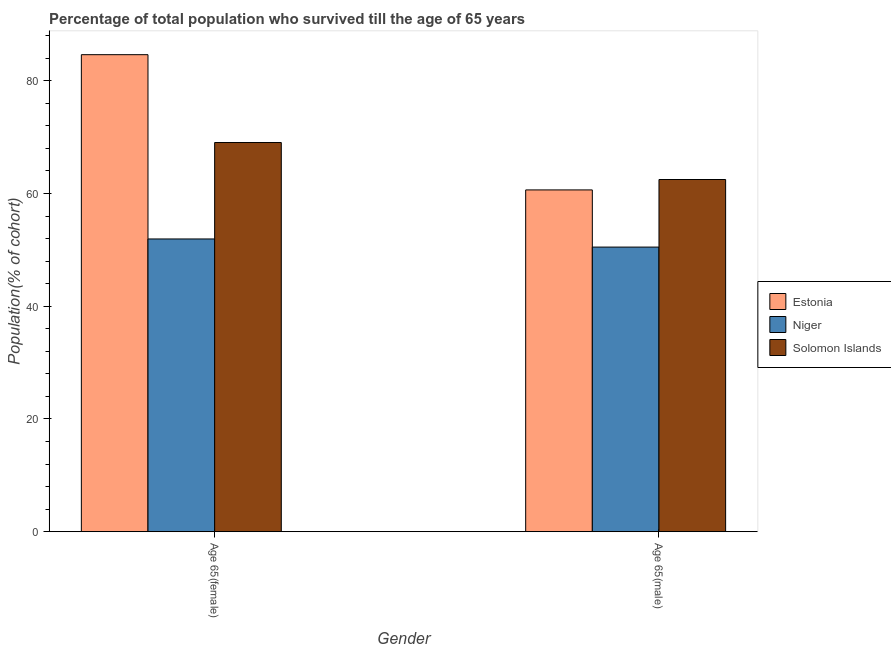How many different coloured bars are there?
Offer a terse response. 3. Are the number of bars per tick equal to the number of legend labels?
Make the answer very short. Yes. How many bars are there on the 2nd tick from the left?
Offer a terse response. 3. How many bars are there on the 2nd tick from the right?
Your answer should be very brief. 3. What is the label of the 1st group of bars from the left?
Give a very brief answer. Age 65(female). What is the percentage of male population who survived till age of 65 in Niger?
Your answer should be very brief. 50.5. Across all countries, what is the maximum percentage of male population who survived till age of 65?
Provide a succinct answer. 62.49. Across all countries, what is the minimum percentage of female population who survived till age of 65?
Your response must be concise. 51.94. In which country was the percentage of female population who survived till age of 65 maximum?
Offer a very short reply. Estonia. In which country was the percentage of male population who survived till age of 65 minimum?
Your response must be concise. Niger. What is the total percentage of male population who survived till age of 65 in the graph?
Your response must be concise. 173.63. What is the difference between the percentage of female population who survived till age of 65 in Niger and that in Solomon Islands?
Your response must be concise. -17.11. What is the difference between the percentage of male population who survived till age of 65 in Niger and the percentage of female population who survived till age of 65 in Solomon Islands?
Offer a terse response. -18.55. What is the average percentage of female population who survived till age of 65 per country?
Your response must be concise. 68.54. What is the difference between the percentage of male population who survived till age of 65 and percentage of female population who survived till age of 65 in Solomon Islands?
Provide a succinct answer. -6.56. What is the ratio of the percentage of male population who survived till age of 65 in Niger to that in Estonia?
Offer a very short reply. 0.83. What does the 3rd bar from the left in Age 65(female) represents?
Keep it short and to the point. Solomon Islands. What does the 2nd bar from the right in Age 65(female) represents?
Offer a terse response. Niger. Are all the bars in the graph horizontal?
Offer a very short reply. No. Are the values on the major ticks of Y-axis written in scientific E-notation?
Keep it short and to the point. No. How many legend labels are there?
Ensure brevity in your answer.  3. What is the title of the graph?
Offer a very short reply. Percentage of total population who survived till the age of 65 years. Does "Syrian Arab Republic" appear as one of the legend labels in the graph?
Your response must be concise. No. What is the label or title of the X-axis?
Offer a very short reply. Gender. What is the label or title of the Y-axis?
Make the answer very short. Population(% of cohort). What is the Population(% of cohort) in Estonia in Age 65(female)?
Ensure brevity in your answer.  84.64. What is the Population(% of cohort) of Niger in Age 65(female)?
Your answer should be very brief. 51.94. What is the Population(% of cohort) in Solomon Islands in Age 65(female)?
Your answer should be compact. 69.05. What is the Population(% of cohort) of Estonia in Age 65(male)?
Provide a short and direct response. 60.64. What is the Population(% of cohort) in Niger in Age 65(male)?
Keep it short and to the point. 50.5. What is the Population(% of cohort) of Solomon Islands in Age 65(male)?
Offer a terse response. 62.49. Across all Gender, what is the maximum Population(% of cohort) in Estonia?
Provide a short and direct response. 84.64. Across all Gender, what is the maximum Population(% of cohort) of Niger?
Your response must be concise. 51.94. Across all Gender, what is the maximum Population(% of cohort) of Solomon Islands?
Your answer should be very brief. 69.05. Across all Gender, what is the minimum Population(% of cohort) in Estonia?
Provide a succinct answer. 60.64. Across all Gender, what is the minimum Population(% of cohort) in Niger?
Provide a succinct answer. 50.5. Across all Gender, what is the minimum Population(% of cohort) in Solomon Islands?
Provide a succinct answer. 62.49. What is the total Population(% of cohort) of Estonia in the graph?
Provide a succinct answer. 145.28. What is the total Population(% of cohort) in Niger in the graph?
Offer a terse response. 102.44. What is the total Population(% of cohort) of Solomon Islands in the graph?
Keep it short and to the point. 131.54. What is the difference between the Population(% of cohort) in Estonia in Age 65(female) and that in Age 65(male)?
Give a very brief answer. 24. What is the difference between the Population(% of cohort) in Niger in Age 65(female) and that in Age 65(male)?
Offer a terse response. 1.44. What is the difference between the Population(% of cohort) of Solomon Islands in Age 65(female) and that in Age 65(male)?
Ensure brevity in your answer.  6.56. What is the difference between the Population(% of cohort) of Estonia in Age 65(female) and the Population(% of cohort) of Niger in Age 65(male)?
Offer a terse response. 34.14. What is the difference between the Population(% of cohort) of Estonia in Age 65(female) and the Population(% of cohort) of Solomon Islands in Age 65(male)?
Keep it short and to the point. 22.15. What is the difference between the Population(% of cohort) of Niger in Age 65(female) and the Population(% of cohort) of Solomon Islands in Age 65(male)?
Give a very brief answer. -10.55. What is the average Population(% of cohort) in Estonia per Gender?
Offer a terse response. 72.64. What is the average Population(% of cohort) in Niger per Gender?
Your response must be concise. 51.22. What is the average Population(% of cohort) in Solomon Islands per Gender?
Provide a succinct answer. 65.77. What is the difference between the Population(% of cohort) in Estonia and Population(% of cohort) in Niger in Age 65(female)?
Your answer should be very brief. 32.7. What is the difference between the Population(% of cohort) of Estonia and Population(% of cohort) of Solomon Islands in Age 65(female)?
Your response must be concise. 15.59. What is the difference between the Population(% of cohort) of Niger and Population(% of cohort) of Solomon Islands in Age 65(female)?
Keep it short and to the point. -17.11. What is the difference between the Population(% of cohort) in Estonia and Population(% of cohort) in Niger in Age 65(male)?
Make the answer very short. 10.14. What is the difference between the Population(% of cohort) of Estonia and Population(% of cohort) of Solomon Islands in Age 65(male)?
Provide a short and direct response. -1.85. What is the difference between the Population(% of cohort) in Niger and Population(% of cohort) in Solomon Islands in Age 65(male)?
Provide a short and direct response. -11.99. What is the ratio of the Population(% of cohort) in Estonia in Age 65(female) to that in Age 65(male)?
Make the answer very short. 1.4. What is the ratio of the Population(% of cohort) of Niger in Age 65(female) to that in Age 65(male)?
Provide a succinct answer. 1.03. What is the ratio of the Population(% of cohort) in Solomon Islands in Age 65(female) to that in Age 65(male)?
Your answer should be very brief. 1.1. What is the difference between the highest and the second highest Population(% of cohort) in Estonia?
Your answer should be compact. 24. What is the difference between the highest and the second highest Population(% of cohort) of Niger?
Offer a very short reply. 1.44. What is the difference between the highest and the second highest Population(% of cohort) of Solomon Islands?
Your answer should be compact. 6.56. What is the difference between the highest and the lowest Population(% of cohort) of Estonia?
Keep it short and to the point. 24. What is the difference between the highest and the lowest Population(% of cohort) of Niger?
Give a very brief answer. 1.44. What is the difference between the highest and the lowest Population(% of cohort) in Solomon Islands?
Give a very brief answer. 6.56. 